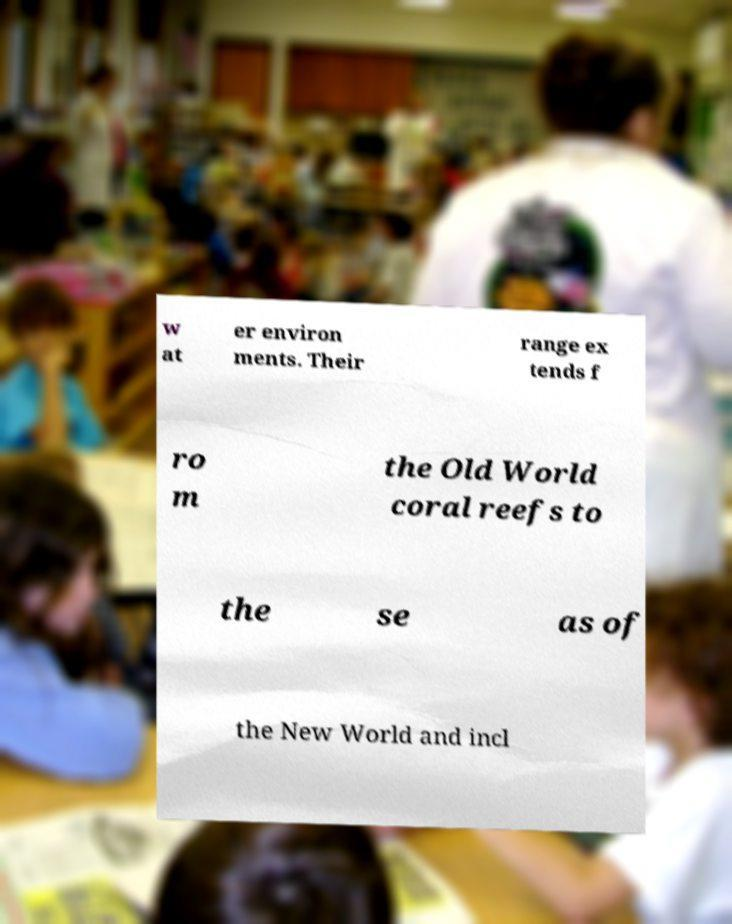Could you assist in decoding the text presented in this image and type it out clearly? w at er environ ments. Their range ex tends f ro m the Old World coral reefs to the se as of the New World and incl 